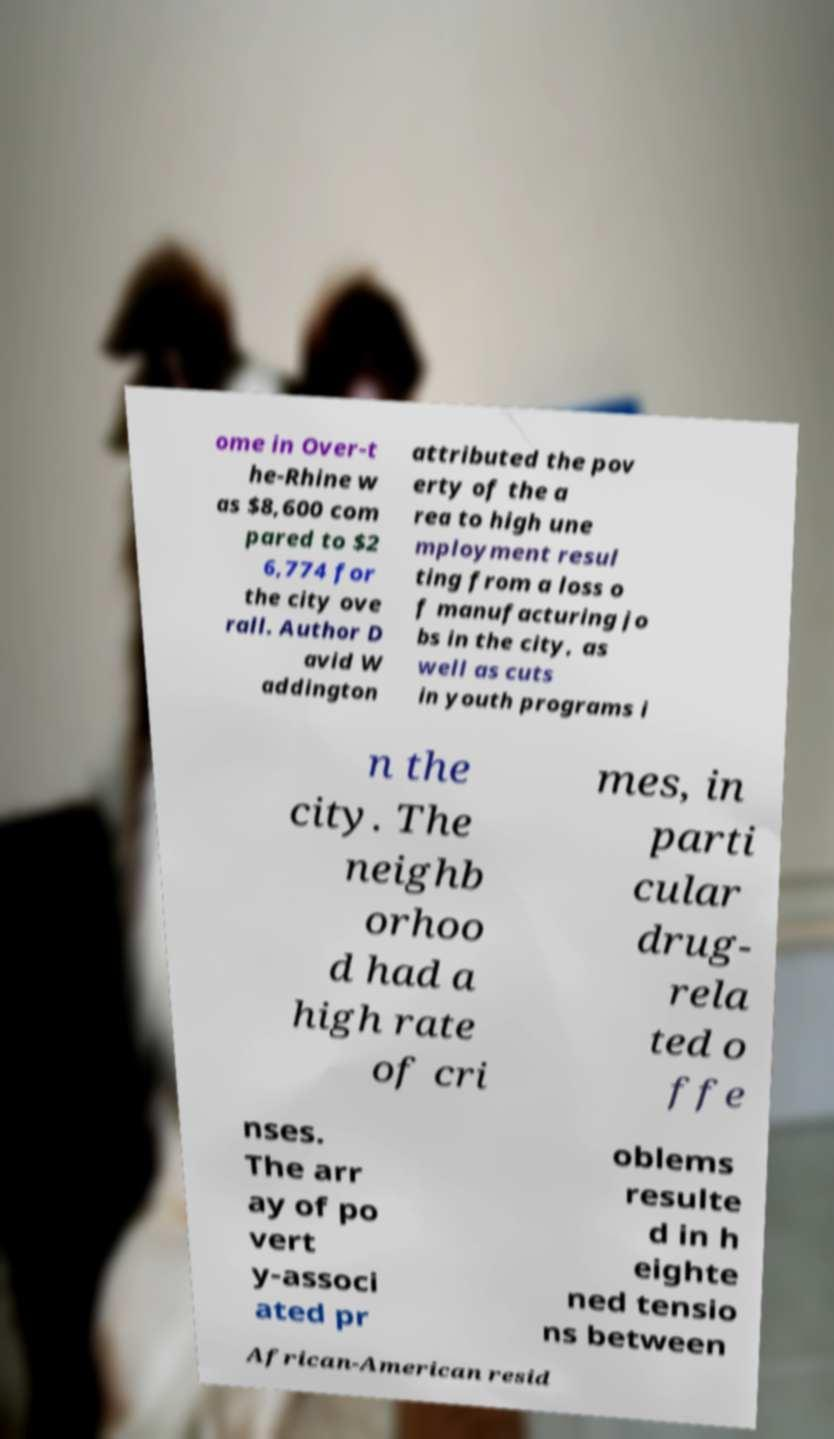Could you extract and type out the text from this image? ome in Over-t he-Rhine w as $8,600 com pared to $2 6,774 for the city ove rall. Author D avid W addington attributed the pov erty of the a rea to high une mployment resul ting from a loss o f manufacturing jo bs in the city, as well as cuts in youth programs i n the city. The neighb orhoo d had a high rate of cri mes, in parti cular drug- rela ted o ffe nses. The arr ay of po vert y-associ ated pr oblems resulte d in h eighte ned tensio ns between African-American resid 